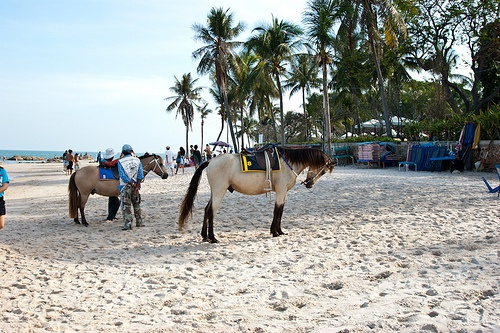Describe the objects in this image and their specific colors. I can see horse in lightblue, black, darkgray, and gray tones, horse in lightblue, gray, black, and maroon tones, people in lightblue, black, gray, lightgray, and darkgray tones, people in lightblue, white, darkgray, black, and gray tones, and people in lightblue, black, lightgray, and darkgray tones in this image. 